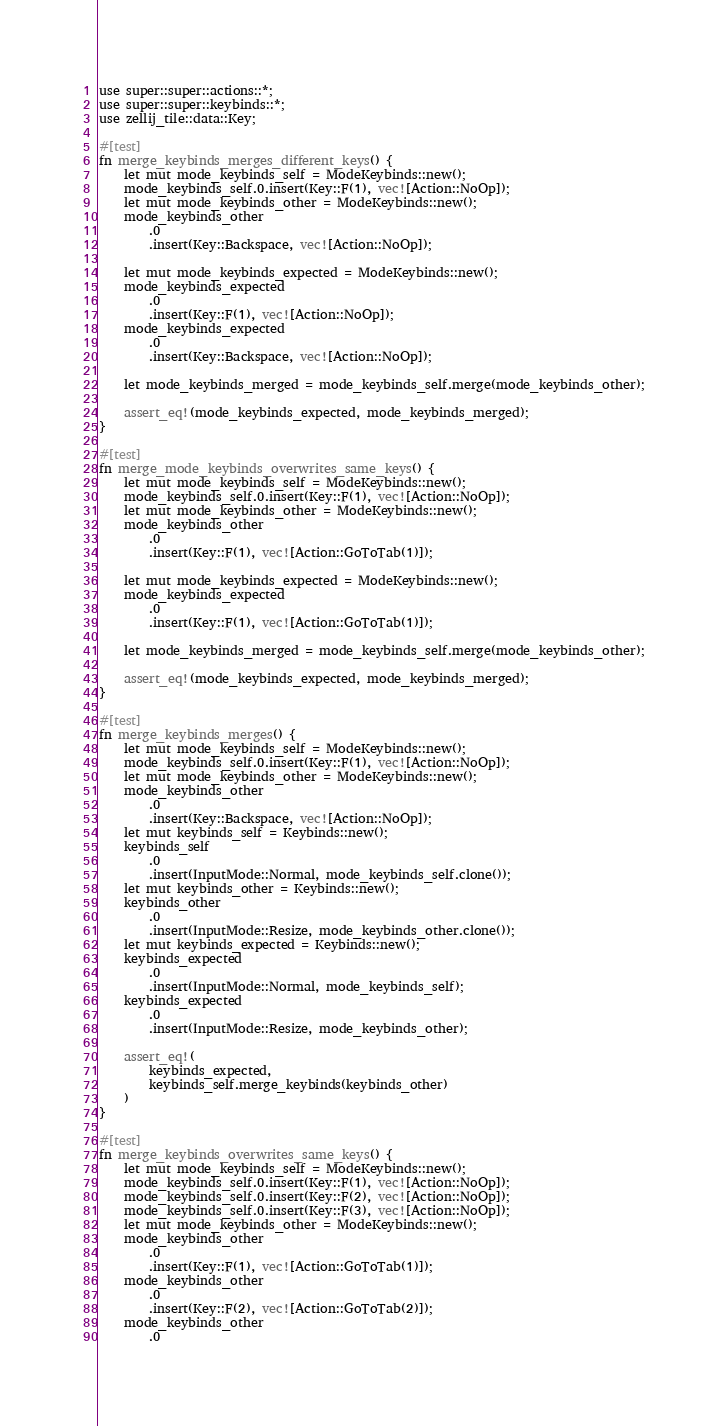Convert code to text. <code><loc_0><loc_0><loc_500><loc_500><_Rust_>use super::super::actions::*;
use super::super::keybinds::*;
use zellij_tile::data::Key;

#[test]
fn merge_keybinds_merges_different_keys() {
    let mut mode_keybinds_self = ModeKeybinds::new();
    mode_keybinds_self.0.insert(Key::F(1), vec![Action::NoOp]);
    let mut mode_keybinds_other = ModeKeybinds::new();
    mode_keybinds_other
        .0
        .insert(Key::Backspace, vec![Action::NoOp]);

    let mut mode_keybinds_expected = ModeKeybinds::new();
    mode_keybinds_expected
        .0
        .insert(Key::F(1), vec![Action::NoOp]);
    mode_keybinds_expected
        .0
        .insert(Key::Backspace, vec![Action::NoOp]);

    let mode_keybinds_merged = mode_keybinds_self.merge(mode_keybinds_other);

    assert_eq!(mode_keybinds_expected, mode_keybinds_merged);
}

#[test]
fn merge_mode_keybinds_overwrites_same_keys() {
    let mut mode_keybinds_self = ModeKeybinds::new();
    mode_keybinds_self.0.insert(Key::F(1), vec![Action::NoOp]);
    let mut mode_keybinds_other = ModeKeybinds::new();
    mode_keybinds_other
        .0
        .insert(Key::F(1), vec![Action::GoToTab(1)]);

    let mut mode_keybinds_expected = ModeKeybinds::new();
    mode_keybinds_expected
        .0
        .insert(Key::F(1), vec![Action::GoToTab(1)]);

    let mode_keybinds_merged = mode_keybinds_self.merge(mode_keybinds_other);

    assert_eq!(mode_keybinds_expected, mode_keybinds_merged);
}

#[test]
fn merge_keybinds_merges() {
    let mut mode_keybinds_self = ModeKeybinds::new();
    mode_keybinds_self.0.insert(Key::F(1), vec![Action::NoOp]);
    let mut mode_keybinds_other = ModeKeybinds::new();
    mode_keybinds_other
        .0
        .insert(Key::Backspace, vec![Action::NoOp]);
    let mut keybinds_self = Keybinds::new();
    keybinds_self
        .0
        .insert(InputMode::Normal, mode_keybinds_self.clone());
    let mut keybinds_other = Keybinds::new();
    keybinds_other
        .0
        .insert(InputMode::Resize, mode_keybinds_other.clone());
    let mut keybinds_expected = Keybinds::new();
    keybinds_expected
        .0
        .insert(InputMode::Normal, mode_keybinds_self);
    keybinds_expected
        .0
        .insert(InputMode::Resize, mode_keybinds_other);

    assert_eq!(
        keybinds_expected,
        keybinds_self.merge_keybinds(keybinds_other)
    )
}

#[test]
fn merge_keybinds_overwrites_same_keys() {
    let mut mode_keybinds_self = ModeKeybinds::new();
    mode_keybinds_self.0.insert(Key::F(1), vec![Action::NoOp]);
    mode_keybinds_self.0.insert(Key::F(2), vec![Action::NoOp]);
    mode_keybinds_self.0.insert(Key::F(3), vec![Action::NoOp]);
    let mut mode_keybinds_other = ModeKeybinds::new();
    mode_keybinds_other
        .0
        .insert(Key::F(1), vec![Action::GoToTab(1)]);
    mode_keybinds_other
        .0
        .insert(Key::F(2), vec![Action::GoToTab(2)]);
    mode_keybinds_other
        .0</code> 